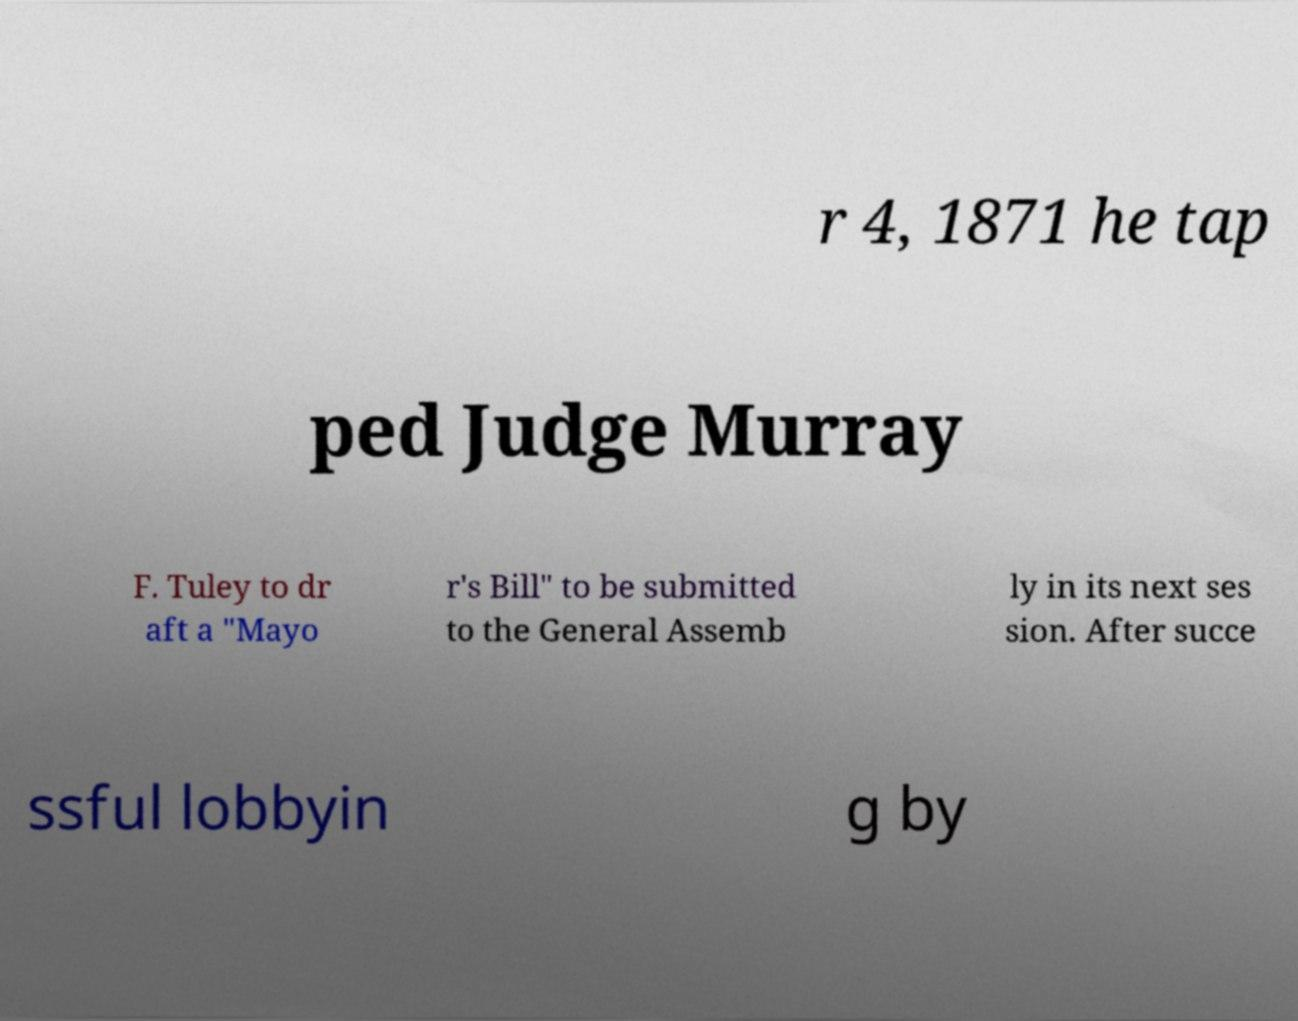Can you accurately transcribe the text from the provided image for me? r 4, 1871 he tap ped Judge Murray F. Tuley to dr aft a "Mayo r's Bill" to be submitted to the General Assemb ly in its next ses sion. After succe ssful lobbyin g by 